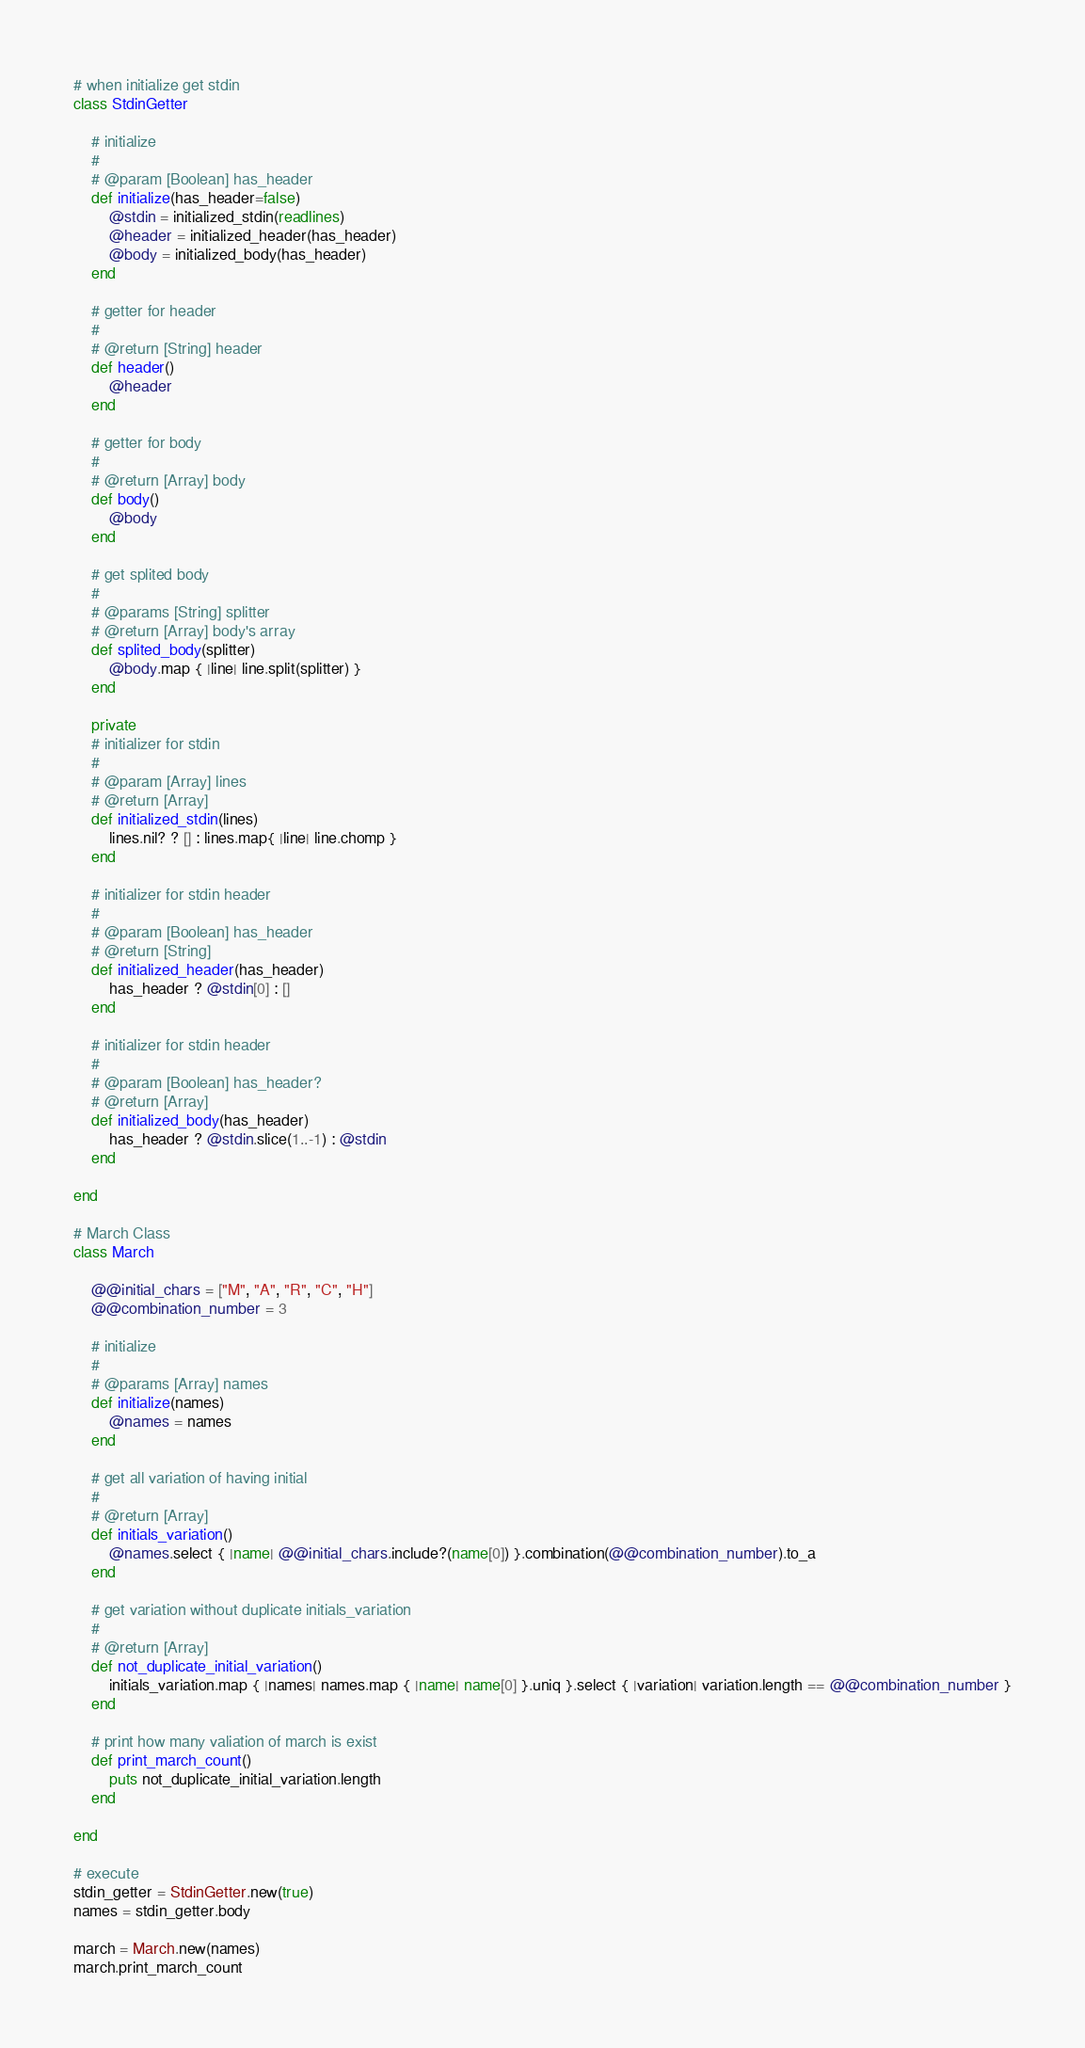Convert code to text. <code><loc_0><loc_0><loc_500><loc_500><_Ruby_># when initialize get stdin
class StdinGetter
    
    # initialize
    #
    # @param [Boolean] has_header
    def initialize(has_header=false)
        @stdin = initialized_stdin(readlines)
        @header = initialized_header(has_header)
        @body = initialized_body(has_header)
    end
    
    # getter for header
    #
    # @return [String] header
    def header()
        @header
    end
    
    # getter for body
    #
    # @return [Array] body
    def body()
        @body
    end
    
    # get splited body
    #
    # @params [String] splitter
    # @return [Array] body's array
    def splited_body(splitter)
        @body.map { |line| line.split(splitter) }
    end
    
    private
    # initializer for stdin
    #
    # @param [Array] lines
    # @return [Array] 
    def initialized_stdin(lines)
        lines.nil? ? [] : lines.map{ |line| line.chomp }
    end
    
    # initializer for stdin header
    #
    # @param [Boolean] has_header
    # @return [String]
    def initialized_header(has_header)
        has_header ? @stdin[0] : []
    end
    
    # initializer for stdin header
    #
    # @param [Boolean] has_header?
    # @return [Array]    
    def initialized_body(has_header)
        has_header ? @stdin.slice(1..-1) : @stdin
    end
        
end

# March Class
class March
    
    @@initial_chars = ["M", "A", "R", "C", "H"]
    @@combination_number = 3
    
    # initialize
    #
    # @params [Array] names
    def initialize(names)
        @names = names
    end
    
    # get all variation of having initial
    #
    # @return [Array]
    def initials_variation()
        @names.select { |name| @@initial_chars.include?(name[0]) }.combination(@@combination_number).to_a
    end
    
    # get variation without duplicate initials_variation
    # 
    # @return [Array]
    def not_duplicate_initial_variation()
        initials_variation.map { |names| names.map { |name| name[0] }.uniq }.select { |variation| variation.length == @@combination_number }
    end
    
    # print how many valiation of march is exist
    def print_march_count()
        puts not_duplicate_initial_variation.length
    end
    
end

# execute
stdin_getter = StdinGetter.new(true)
names = stdin_getter.body

march = March.new(names)
march.print_march_count</code> 